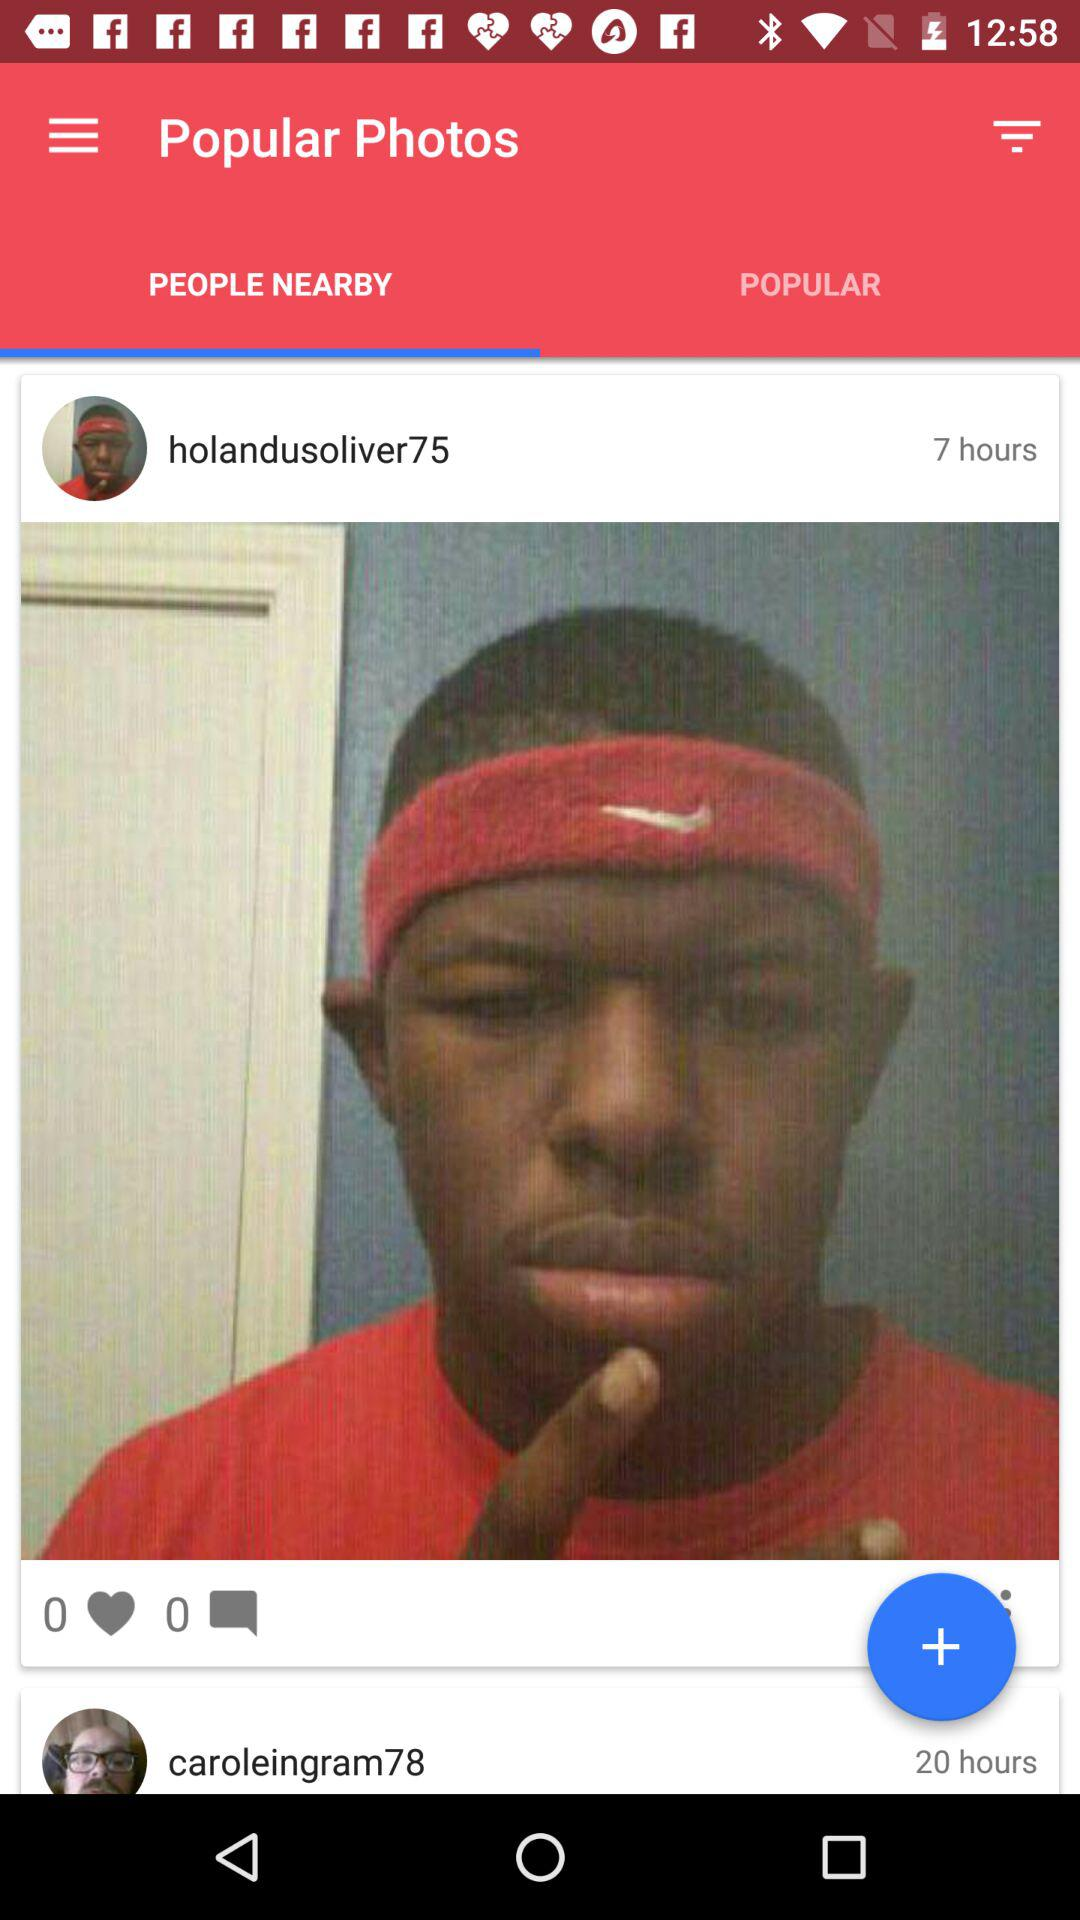How many comments did the profile of "holandusoliver75" get? The profile got 0 comments. 